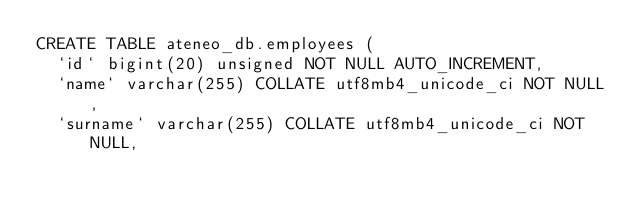Convert code to text. <code><loc_0><loc_0><loc_500><loc_500><_SQL_>CREATE TABLE ateneo_db.employees (
  `id` bigint(20) unsigned NOT NULL AUTO_INCREMENT,
  `name` varchar(255) COLLATE utf8mb4_unicode_ci NOT NULL,
  `surname` varchar(255) COLLATE utf8mb4_unicode_ci NOT NULL,</code> 